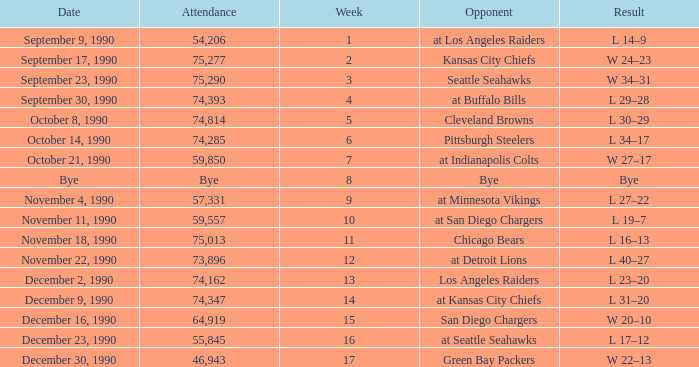Who is the opponent when the attendance is 57,331? At minnesota vikings. 